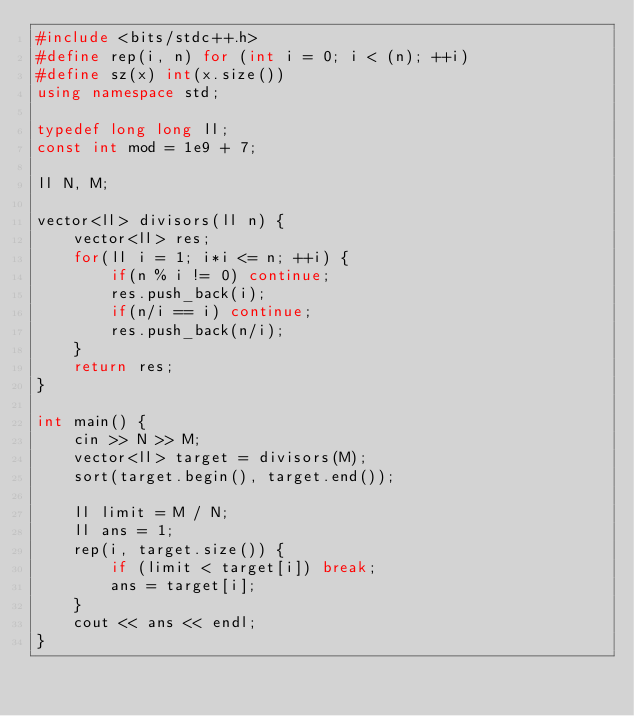Convert code to text. <code><loc_0><loc_0><loc_500><loc_500><_C++_>#include <bits/stdc++.h>
#define rep(i, n) for (int i = 0; i < (n); ++i)
#define sz(x) int(x.size())
using namespace std;

typedef long long ll;
const int mod = 1e9 + 7;

ll N, M;

vector<ll> divisors(ll n) {
    vector<ll> res;
    for(ll i = 1; i*i <= n; ++i) {
        if(n % i != 0) continue;
        res.push_back(i);
        if(n/i == i) continue;
        res.push_back(n/i);
    }
    return res;
}

int main() {
    cin >> N >> M;
    vector<ll> target = divisors(M);
    sort(target.begin(), target.end());

    ll limit = M / N;
    ll ans = 1;
    rep(i, target.size()) {
        if (limit < target[i]) break;
        ans = target[i];
    }
    cout << ans << endl;
}</code> 